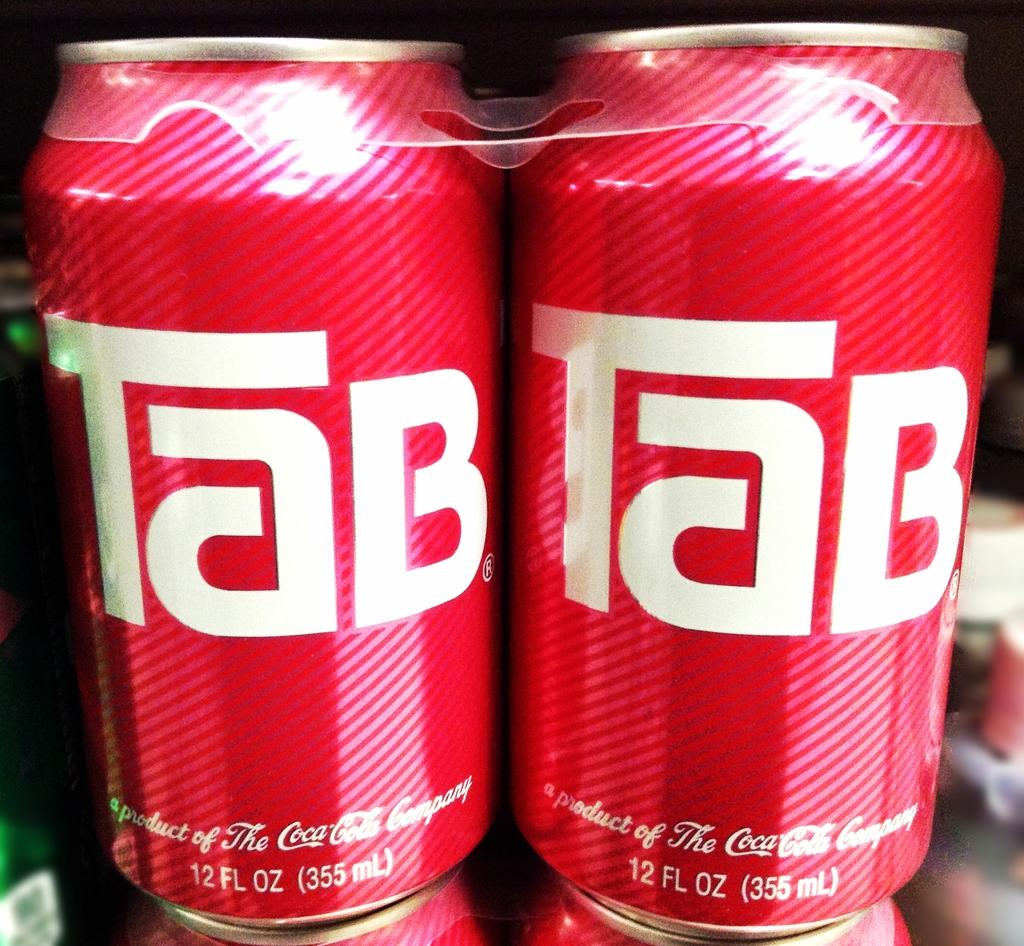<image>
Provide a brief description of the given image. a Tab soda can next to another one 